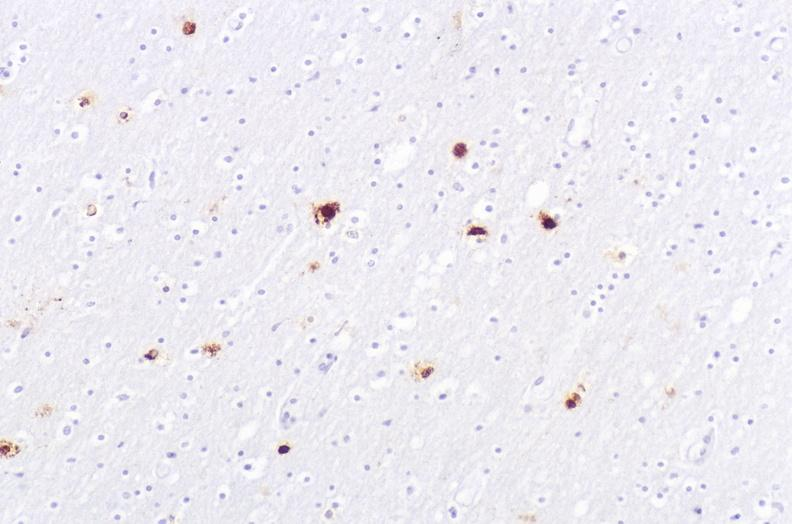s nervous present?
Answer the question using a single word or phrase. Yes 